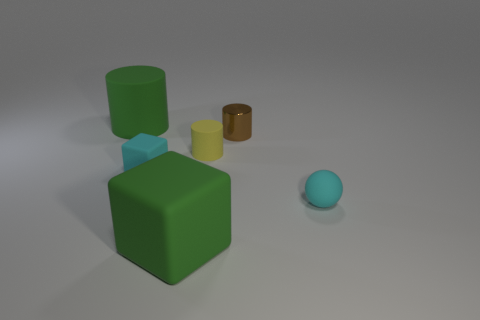Does the small metal thing have the same color as the small block?
Your response must be concise. No. There is a object that is the same color as the large cylinder; what shape is it?
Ensure brevity in your answer.  Cube. What is the color of the other big thing that is the same shape as the yellow object?
Keep it short and to the point. Green. Is there any other thing that is the same shape as the tiny metallic thing?
Keep it short and to the point. Yes. Are there an equal number of tiny cyan matte spheres that are behind the tiny brown metal thing and large spheres?
Offer a terse response. Yes. What number of tiny cyan things are to the left of the shiny cylinder and on the right side of the tiny rubber block?
Keep it short and to the point. 0. What is the size of the other green thing that is the same shape as the metallic object?
Your response must be concise. Large. What number of large green cylinders are made of the same material as the tiny yellow object?
Offer a very short reply. 1. Are there fewer small brown cylinders that are behind the large rubber cylinder than small red balls?
Keep it short and to the point. No. What number of gray rubber balls are there?
Provide a succinct answer. 0. 